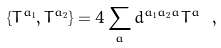Convert formula to latex. <formula><loc_0><loc_0><loc_500><loc_500>\{ T ^ { a _ { 1 } } , T ^ { a _ { 2 } } \} = 4 \sum _ { a } d ^ { a _ { 1 } a _ { 2 } a } T ^ { a } \ ,</formula> 